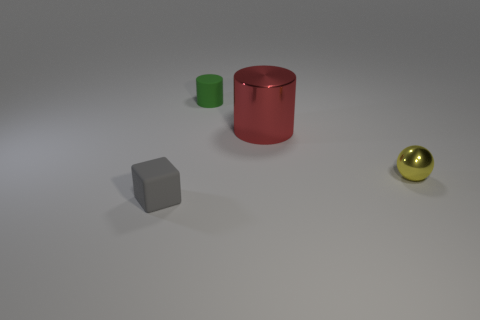Are there any tiny shiny objects that have the same color as the big cylinder?
Provide a succinct answer. No. Are any small rubber things visible?
Your answer should be very brief. Yes. There is a metal thing behind the yellow sphere; is it the same size as the green object?
Your answer should be compact. No. Are there fewer big red shiny cylinders than large gray balls?
Make the answer very short. No. What shape is the matte thing that is behind the cylinder that is right of the tiny rubber thing that is behind the yellow shiny sphere?
Offer a very short reply. Cylinder. Are there any green objects made of the same material as the ball?
Provide a short and direct response. No. Does the shiny thing that is behind the small shiny sphere have the same color as the object on the left side of the small green object?
Keep it short and to the point. No. Are there fewer matte things to the right of the large object than big cyan balls?
Offer a very short reply. No. What number of things are either balls or things to the right of the big red object?
Ensure brevity in your answer.  1. What color is the other object that is made of the same material as the red object?
Your answer should be very brief. Yellow. 